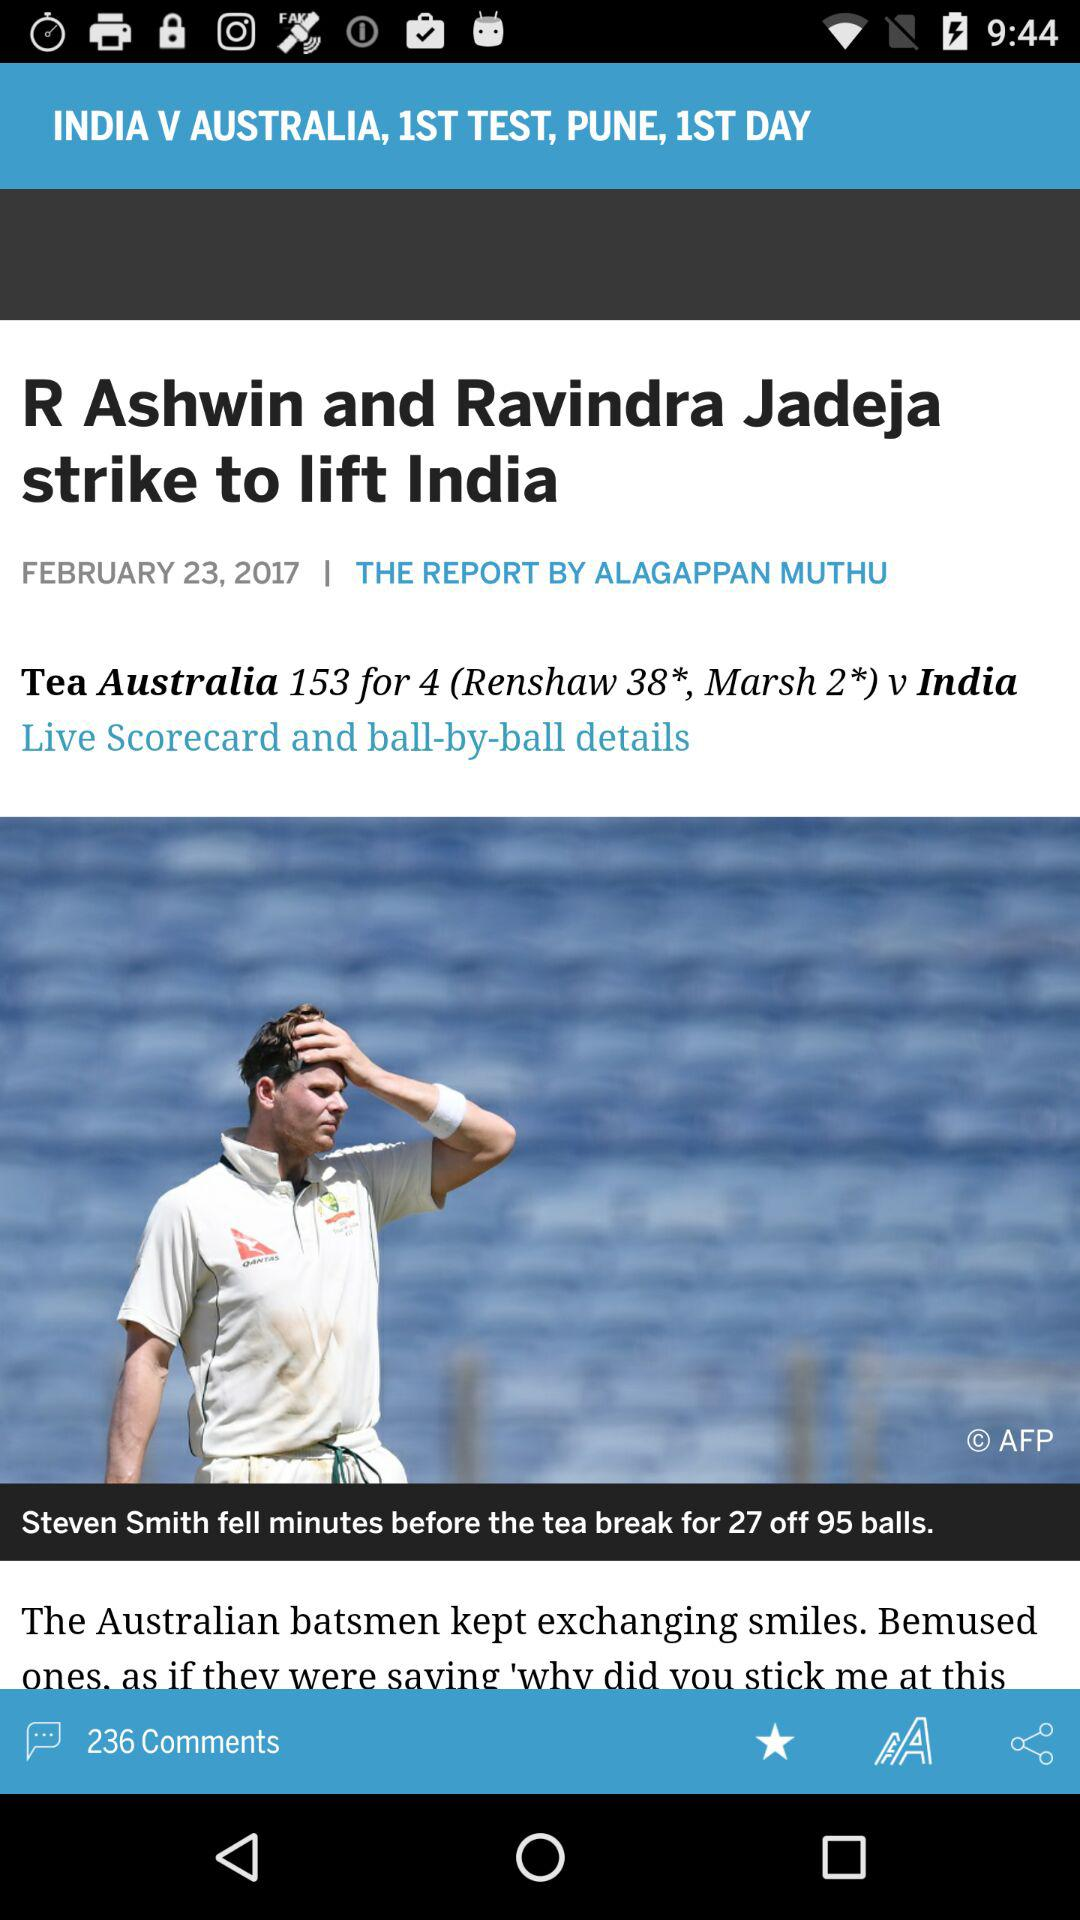What is the publication date? The publication date is February 23, 2017. 